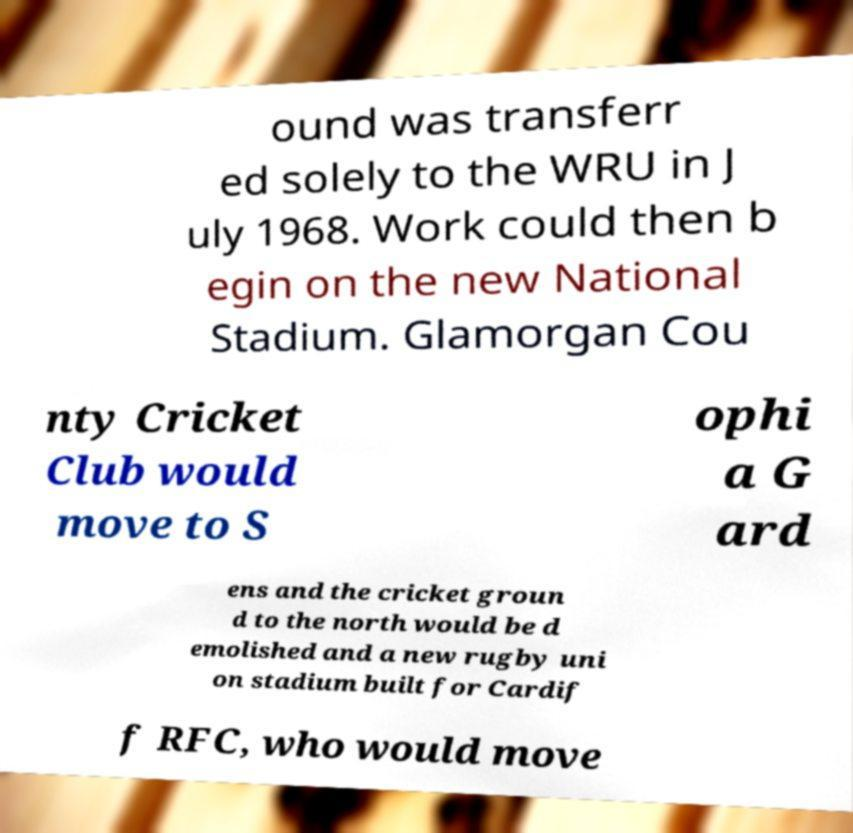Can you accurately transcribe the text from the provided image for me? ound was transferr ed solely to the WRU in J uly 1968. Work could then b egin on the new National Stadium. Glamorgan Cou nty Cricket Club would move to S ophi a G ard ens and the cricket groun d to the north would be d emolished and a new rugby uni on stadium built for Cardif f RFC, who would move 